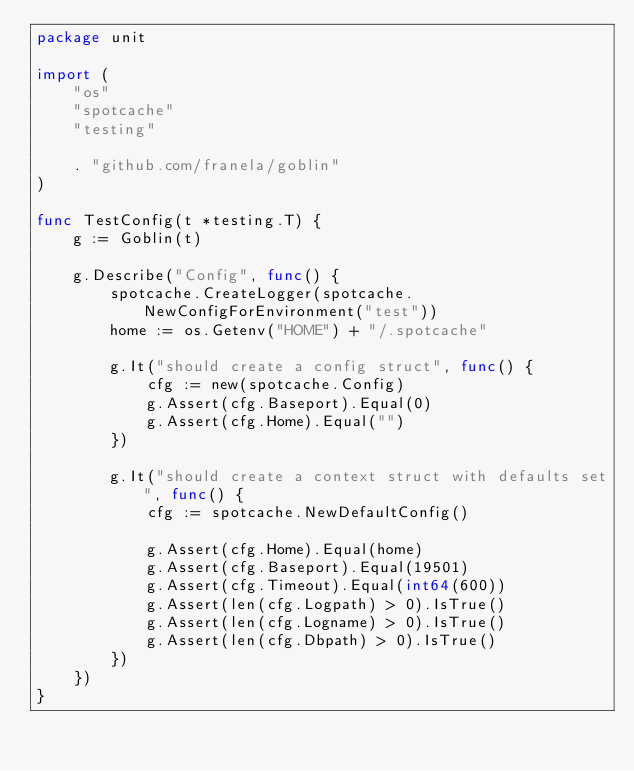<code> <loc_0><loc_0><loc_500><loc_500><_Go_>package unit

import (
	"os"
	"spotcache"
	"testing"

	. "github.com/franela/goblin"
)

func TestConfig(t *testing.T) {
	g := Goblin(t)

	g.Describe("Config", func() {
		spotcache.CreateLogger(spotcache.NewConfigForEnvironment("test"))
		home := os.Getenv("HOME") + "/.spotcache"

		g.It("should create a config struct", func() {
			cfg := new(spotcache.Config)
			g.Assert(cfg.Baseport).Equal(0)
			g.Assert(cfg.Home).Equal("")
		})

		g.It("should create a context struct with defaults set", func() {
			cfg := spotcache.NewDefaultConfig()

			g.Assert(cfg.Home).Equal(home)
			g.Assert(cfg.Baseport).Equal(19501)
			g.Assert(cfg.Timeout).Equal(int64(600))
			g.Assert(len(cfg.Logpath) > 0).IsTrue()
			g.Assert(len(cfg.Logname) > 0).IsTrue()
			g.Assert(len(cfg.Dbpath) > 0).IsTrue()
		})
	})
}
</code> 